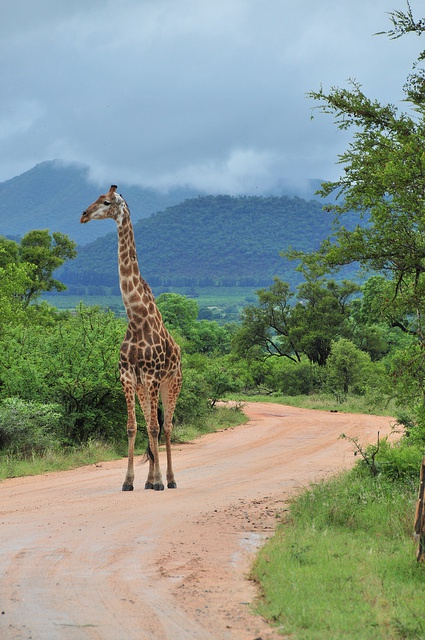Describe the objects in this image and their specific colors. I can see a giraffe in lightblue, gray, maroon, and tan tones in this image. 